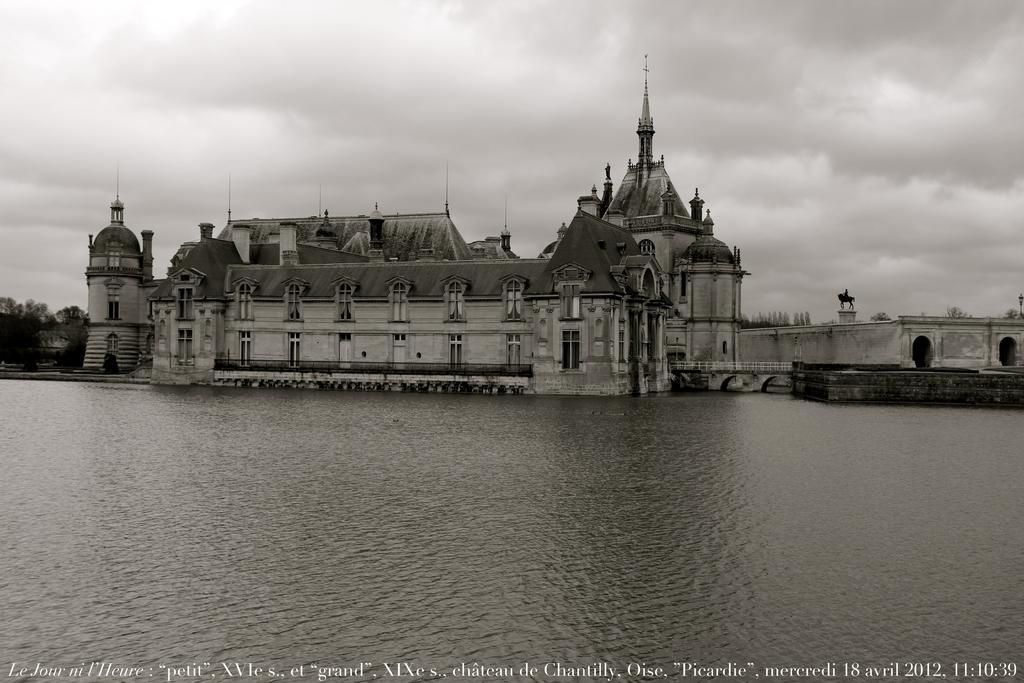In one or two sentences, can you explain what this image depicts? We can see water and building. Background we can see trees and sky. Bottom of the image we can see text. 